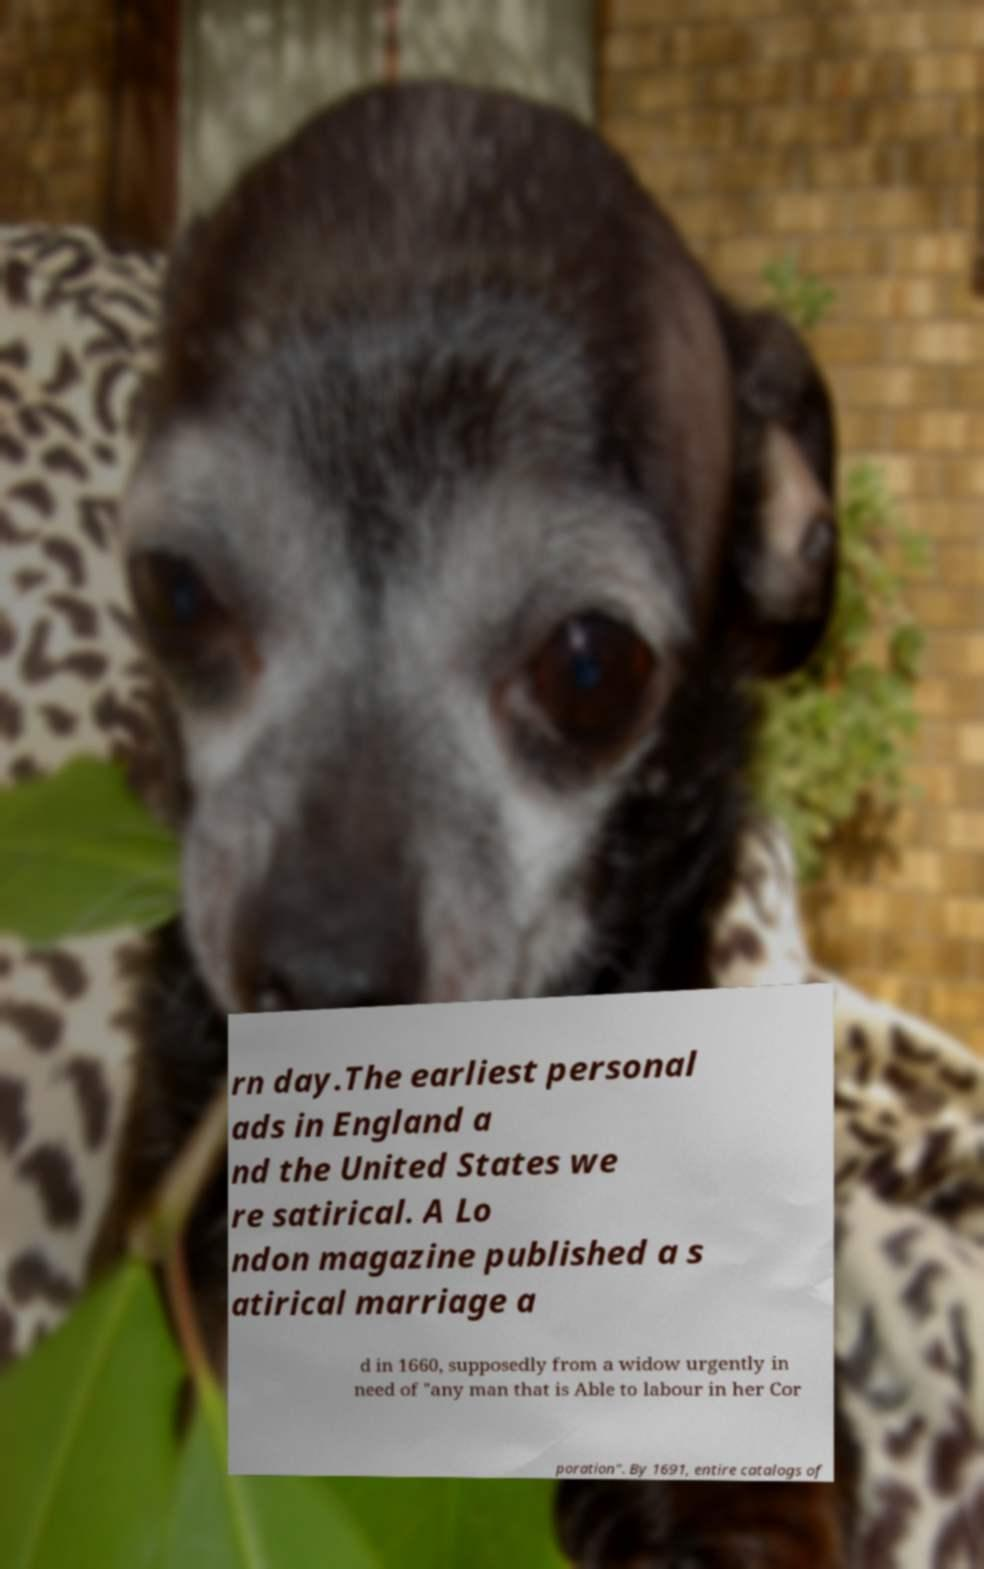Could you extract and type out the text from this image? rn day.The earliest personal ads in England a nd the United States we re satirical. A Lo ndon magazine published a s atirical marriage a d in 1660, supposedly from a widow urgently in need of "any man that is Able to labour in her Cor poration". By 1691, entire catalogs of 